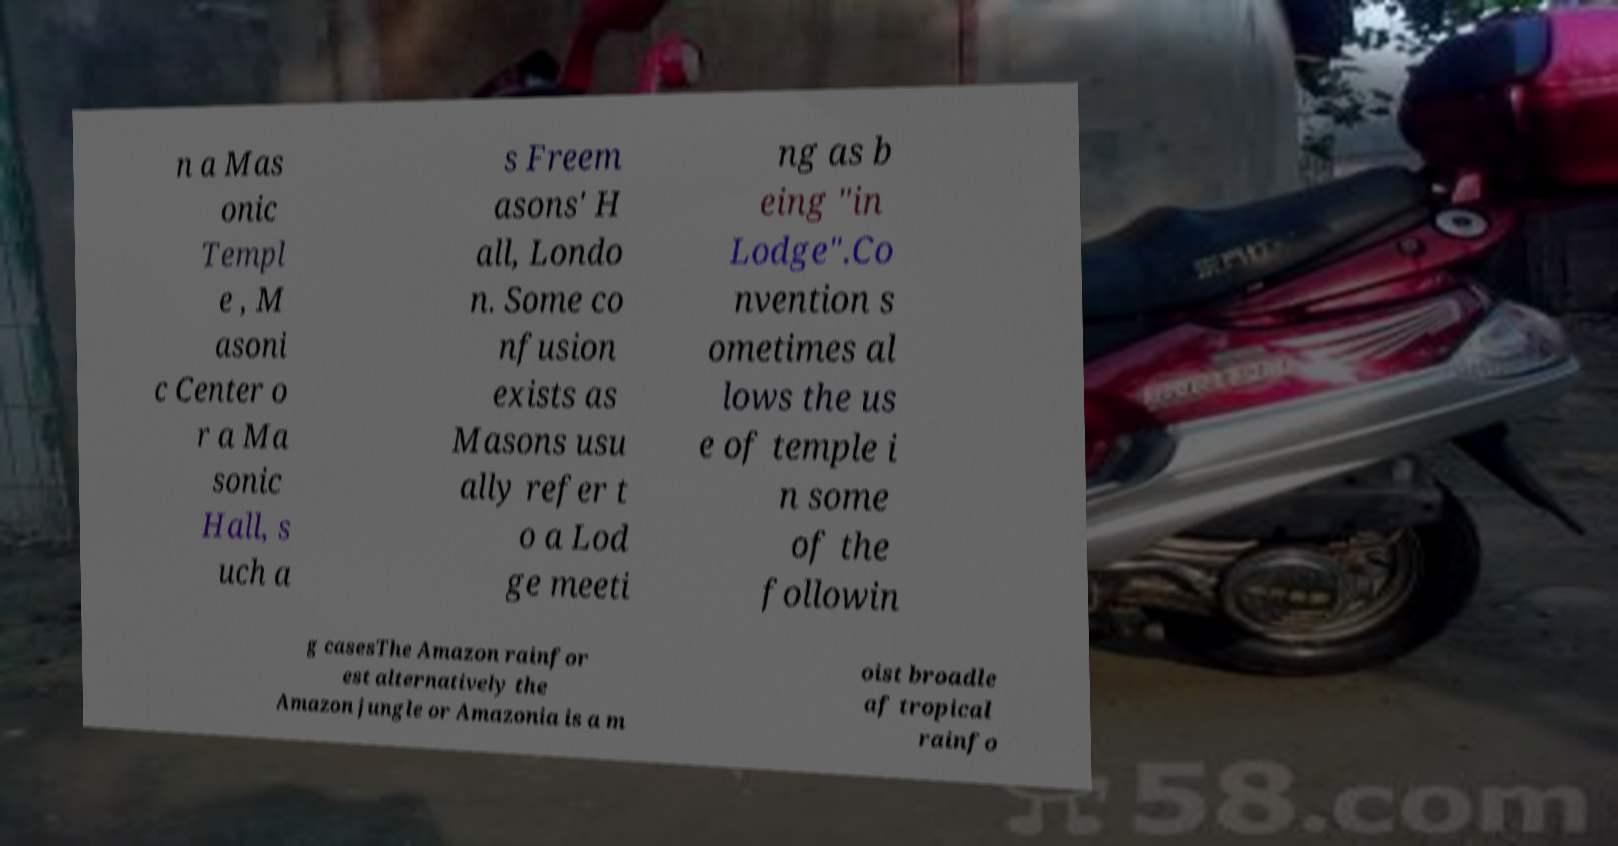For documentation purposes, I need the text within this image transcribed. Could you provide that? n a Mas onic Templ e , M asoni c Center o r a Ma sonic Hall, s uch a s Freem asons' H all, Londo n. Some co nfusion exists as Masons usu ally refer t o a Lod ge meeti ng as b eing "in Lodge".Co nvention s ometimes al lows the us e of temple i n some of the followin g casesThe Amazon rainfor est alternatively the Amazon jungle or Amazonia is a m oist broadle af tropical rainfo 